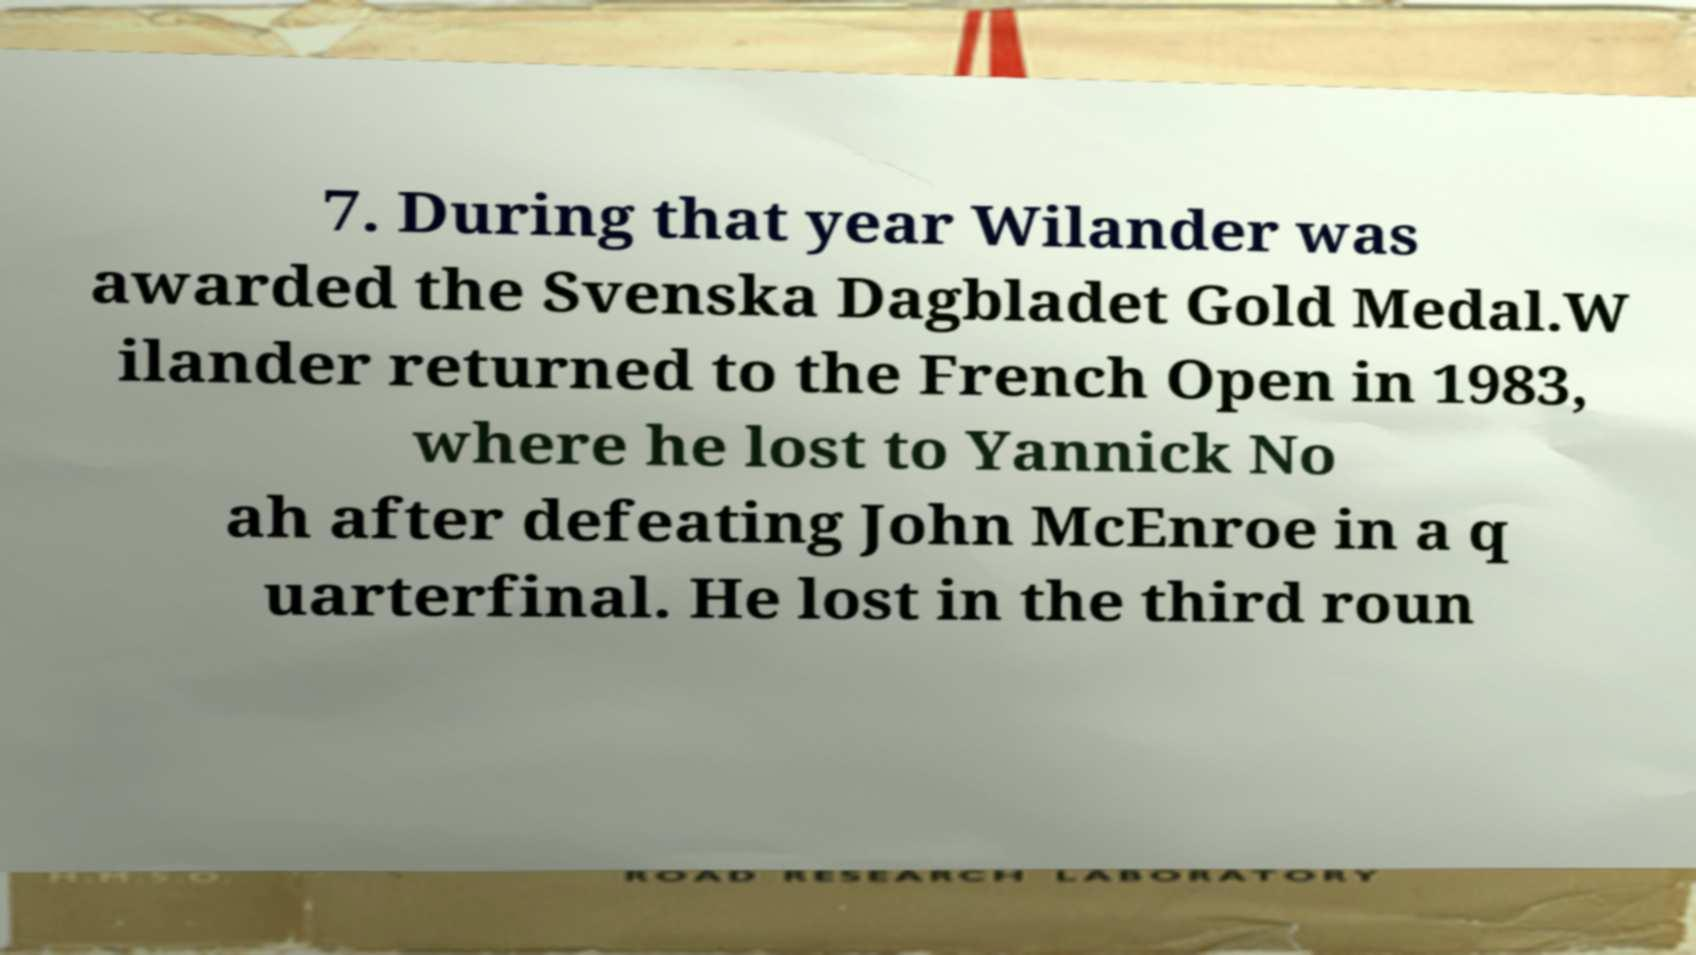For documentation purposes, I need the text within this image transcribed. Could you provide that? 7. During that year Wilander was awarded the Svenska Dagbladet Gold Medal.W ilander returned to the French Open in 1983, where he lost to Yannick No ah after defeating John McEnroe in a q uarterfinal. He lost in the third roun 